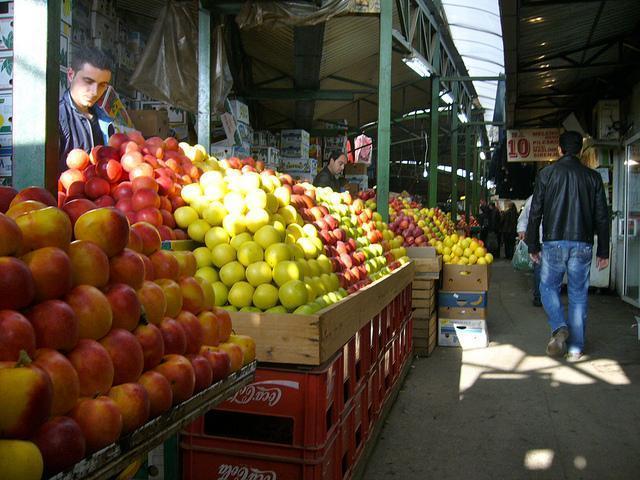How many apples are there?
Give a very brief answer. 4. How many people are there?
Give a very brief answer. 2. 